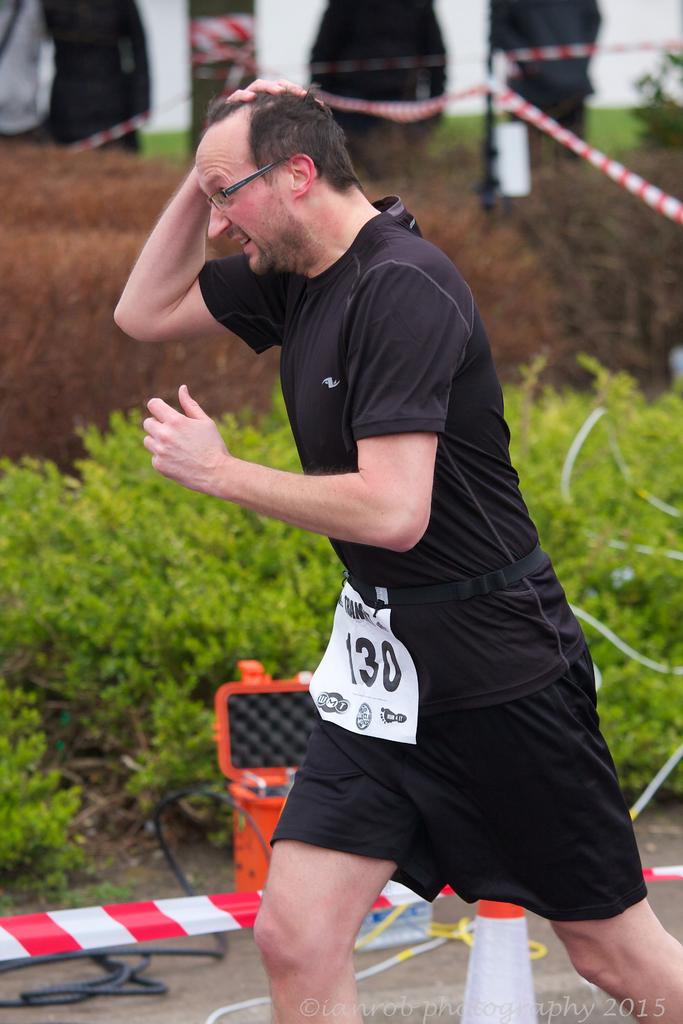What is the person in the image doing? The person is running in the image. On what surface is the person running? The person is running on the ground. What object can be seen in the background of the image? There is a traffic pole in the image. What items are present in the image related to ropes and ribbons? There is a rope and a ribbon in the image. What type of container is visible in the image? There is a container in the image. What type of vegetation is present in the image? There is a group of plants in the image. What disease is the person running from in the image? There is no indication of a disease or any health-related issue in the image; the person is simply running. 